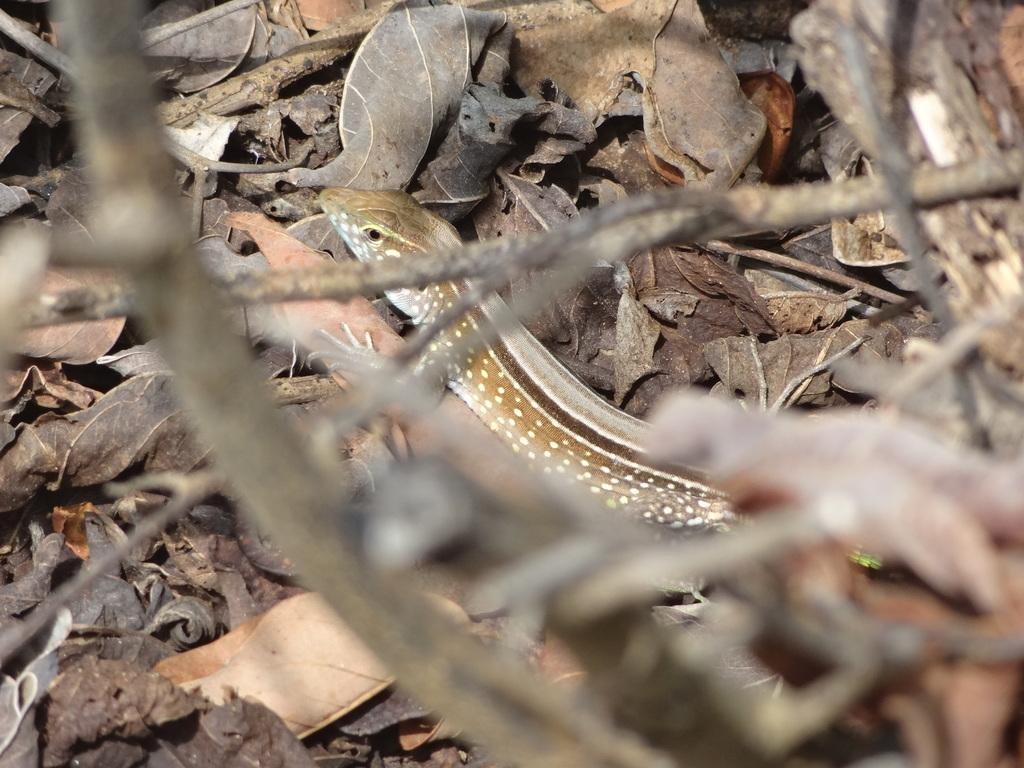What type of animal is in the image? There is a snake in the image. What else can be seen in the image besides the snake? Dry leaves are present in the image. What type of silver object is visible in the image? There is no silver object present in the image. What kind of drug can be seen in the image? There is no drug present in the image. 